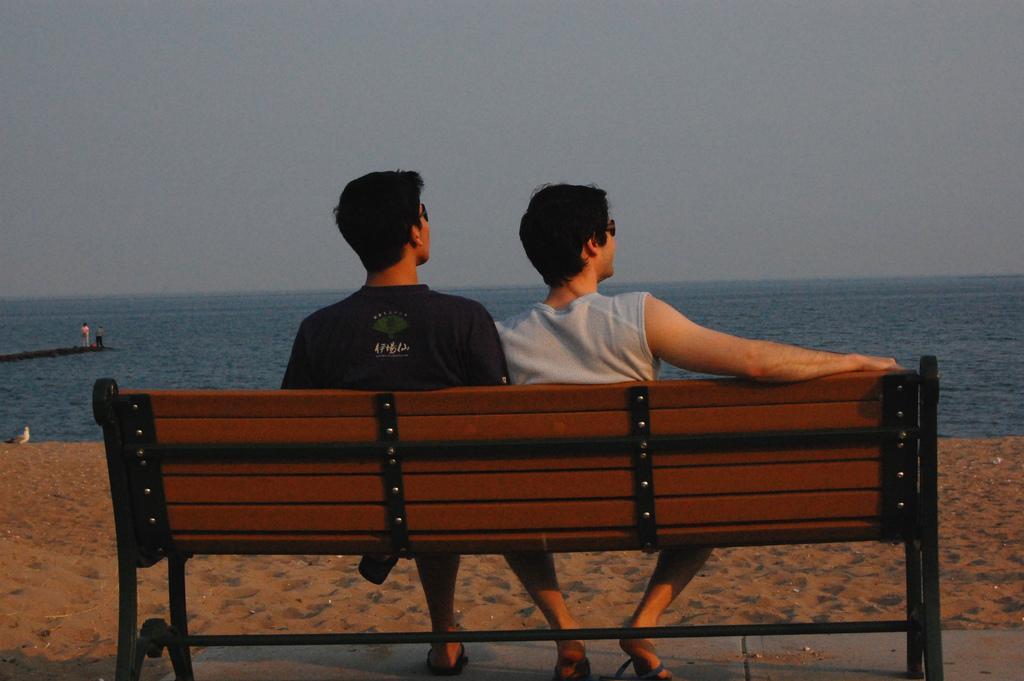In one or two sentences, can you explain what this image depicts? In this image I can see two men are sitting on a bench. Here I can see few more people and water. 